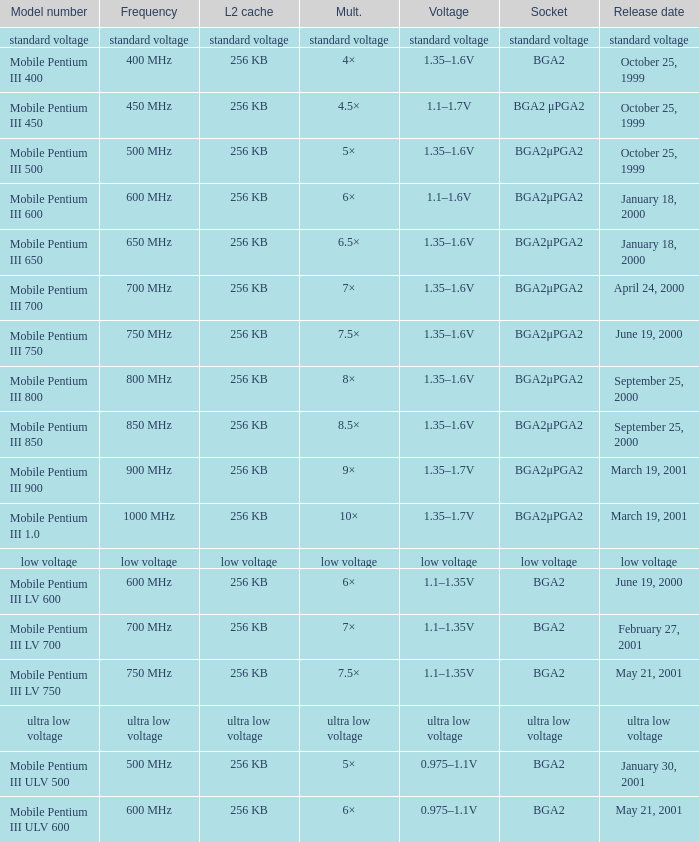Which model has a frequency of 750 mhz and a socket of bga2μpga2? Mobile Pentium III 750. 